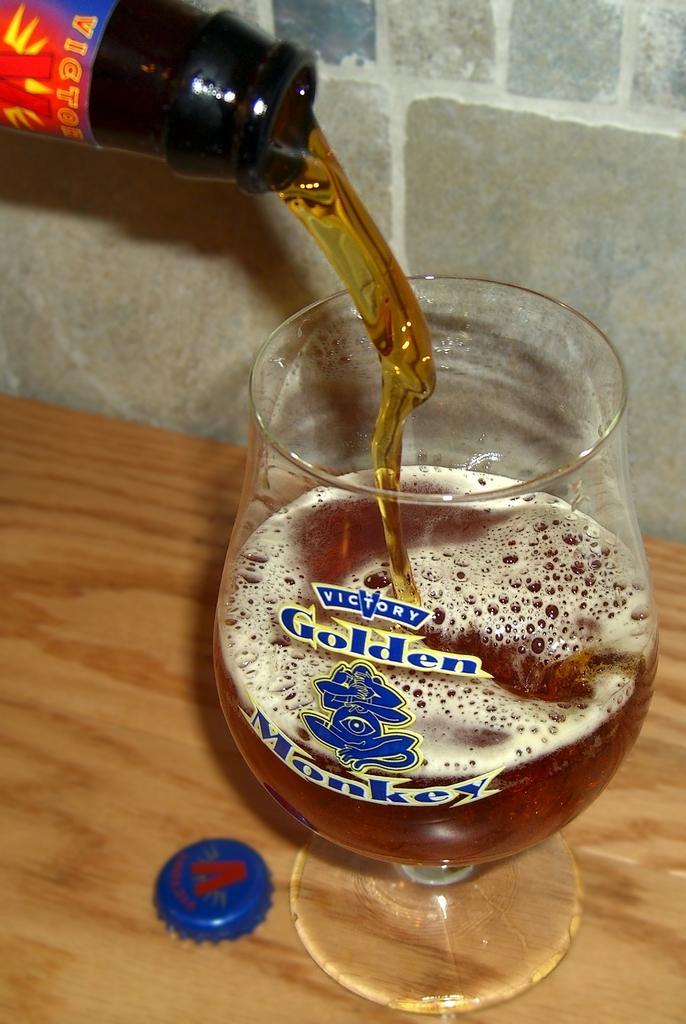Could you give a brief overview of what you see in this image? In this image we can see a glass with a drink in it and with the label on it is placed on the wooden surface. Here we can see the blue color bottle cap and here we can see the bottle from which we can see the drink is coming out. In the background, we can see the stone wall. 